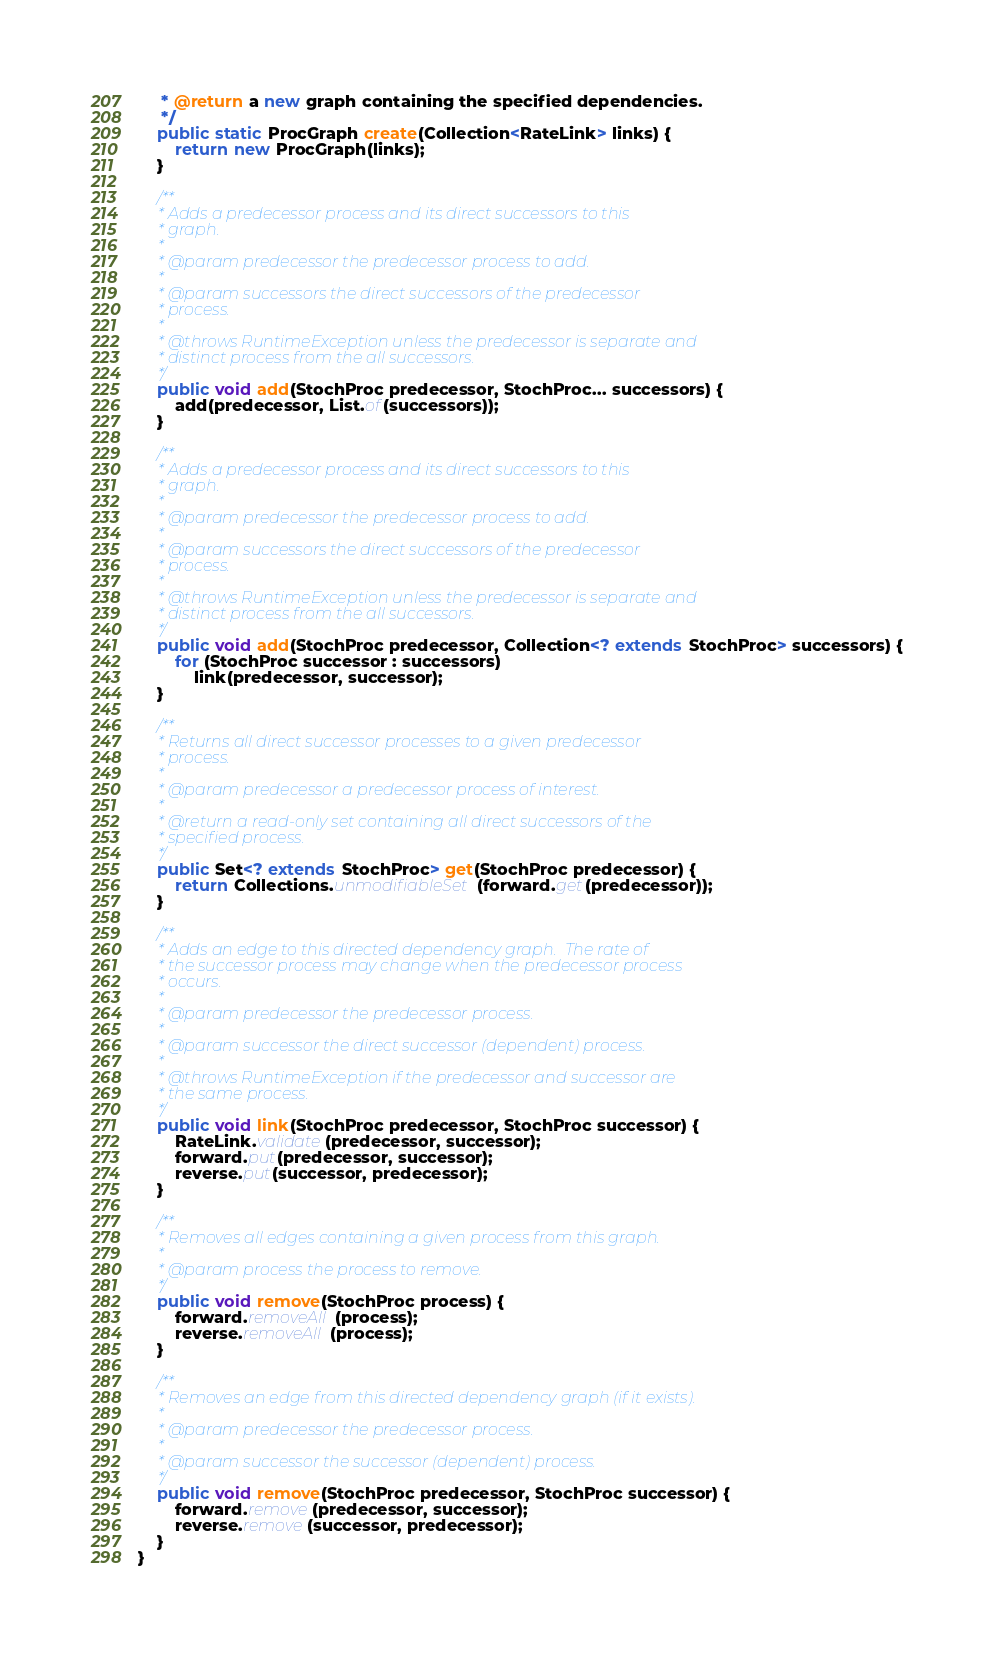Convert code to text. <code><loc_0><loc_0><loc_500><loc_500><_Java_>     * @return a new graph containing the specified dependencies.
     */
    public static ProcGraph create(Collection<RateLink> links) {
        return new ProcGraph(links);
    }

    /**
     * Adds a predecessor process and its direct successors to this
     * graph.
     *
     * @param predecessor the predecessor process to add.
     *
     * @param successors the direct successors of the predecessor
     * process.
     *
     * @throws RuntimeException unless the predecessor is separate and
     * distinct process from the all successors.
     */
    public void add(StochProc predecessor, StochProc... successors) {
        add(predecessor, List.of(successors));
    }

    /**
     * Adds a predecessor process and its direct successors to this
     * graph.
     *
     * @param predecessor the predecessor process to add.
     *
     * @param successors the direct successors of the predecessor
     * process.
     *
     * @throws RuntimeException unless the predecessor is separate and
     * distinct process from the all successors.
     */
    public void add(StochProc predecessor, Collection<? extends StochProc> successors) {
        for (StochProc successor : successors)
            link(predecessor, successor);
    }

    /**
     * Returns all direct successor processes to a given predecessor
     * process.
     *
     * @param predecessor a predecessor process of interest.
     *
     * @return a read-only set containing all direct successors of the
     * specified process.
     */
    public Set<? extends StochProc> get(StochProc predecessor) {
        return Collections.unmodifiableSet(forward.get(predecessor));
    }

    /**
     * Adds an edge to this directed dependency graph.  The rate of
     * the successor process may change when the predecessor process
     * occurs.
     *
     * @param predecessor the predecessor process.
     *
     * @param successor the direct successor (dependent) process.
     *
     * @throws RuntimeException if the predecessor and successor are
     * the same process.
     */
    public void link(StochProc predecessor, StochProc successor) {
        RateLink.validate(predecessor, successor);
        forward.put(predecessor, successor);
        reverse.put(successor, predecessor);
    }

    /**
     * Removes all edges containing a given process from this graph.
     *
     * @param process the process to remove.
     */
    public void remove(StochProc process) {
        forward.removeAll(process);
        reverse.removeAll(process);
    }

    /**
     * Removes an edge from this directed dependency graph (if it exists).
     *
     * @param predecessor the predecessor process.
     *
     * @param successor the successor (dependent) process.
     */
    public void remove(StochProc predecessor, StochProc successor) {
        forward.remove(predecessor, successor);
        reverse.remove(successor, predecessor);
    }
}
</code> 